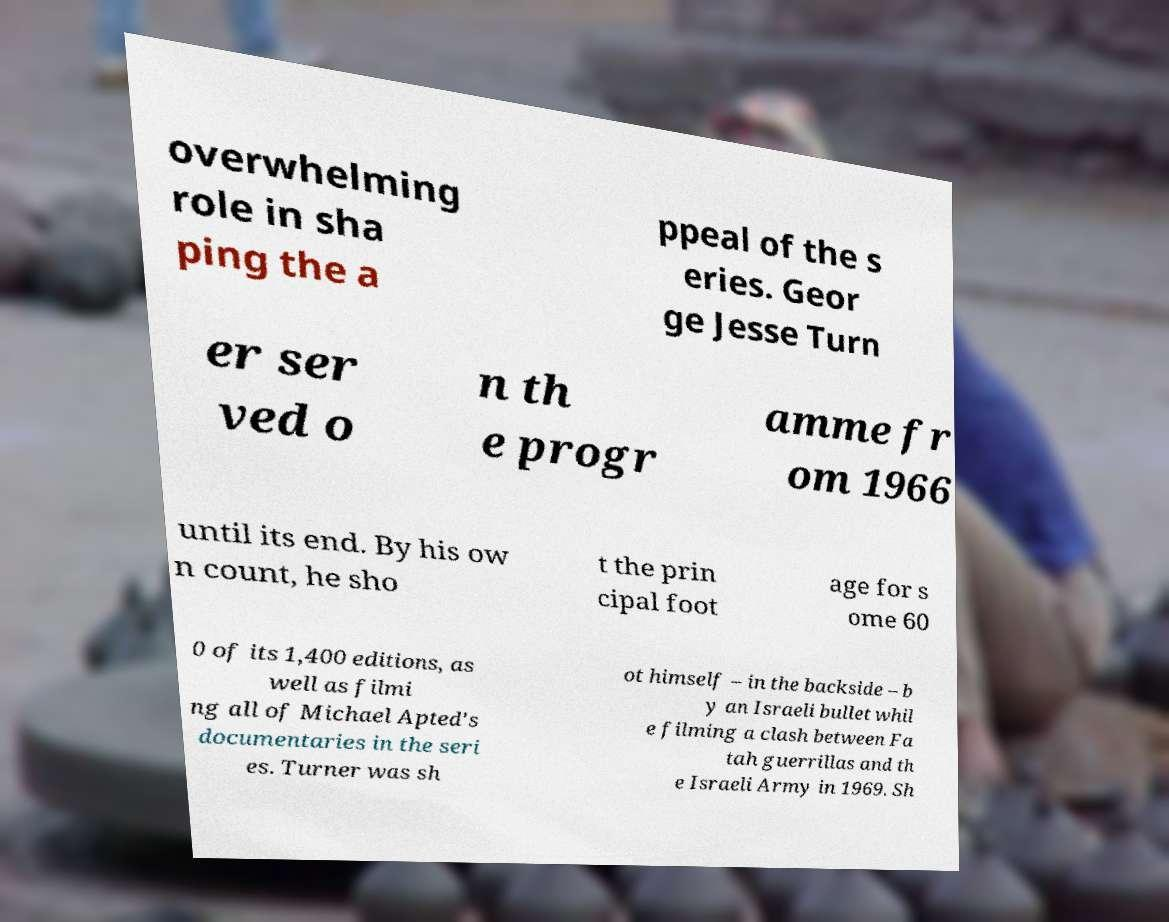I need the written content from this picture converted into text. Can you do that? overwhelming role in sha ping the a ppeal of the s eries. Geor ge Jesse Turn er ser ved o n th e progr amme fr om 1966 until its end. By his ow n count, he sho t the prin cipal foot age for s ome 60 0 of its 1,400 editions, as well as filmi ng all of Michael Apted's documentaries in the seri es. Turner was sh ot himself – in the backside – b y an Israeli bullet whil e filming a clash between Fa tah guerrillas and th e Israeli Army in 1969. Sh 